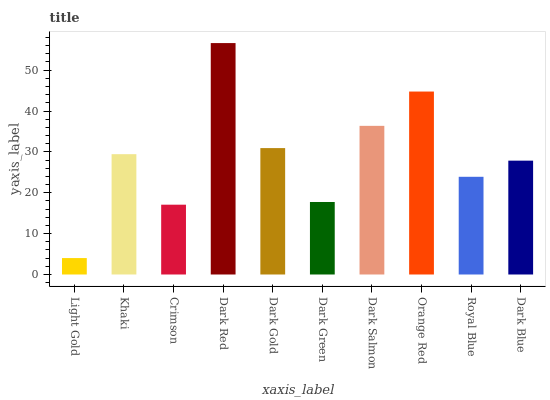Is Light Gold the minimum?
Answer yes or no. Yes. Is Dark Red the maximum?
Answer yes or no. Yes. Is Khaki the minimum?
Answer yes or no. No. Is Khaki the maximum?
Answer yes or no. No. Is Khaki greater than Light Gold?
Answer yes or no. Yes. Is Light Gold less than Khaki?
Answer yes or no. Yes. Is Light Gold greater than Khaki?
Answer yes or no. No. Is Khaki less than Light Gold?
Answer yes or no. No. Is Khaki the high median?
Answer yes or no. Yes. Is Dark Blue the low median?
Answer yes or no. Yes. Is Light Gold the high median?
Answer yes or no. No. Is Royal Blue the low median?
Answer yes or no. No. 